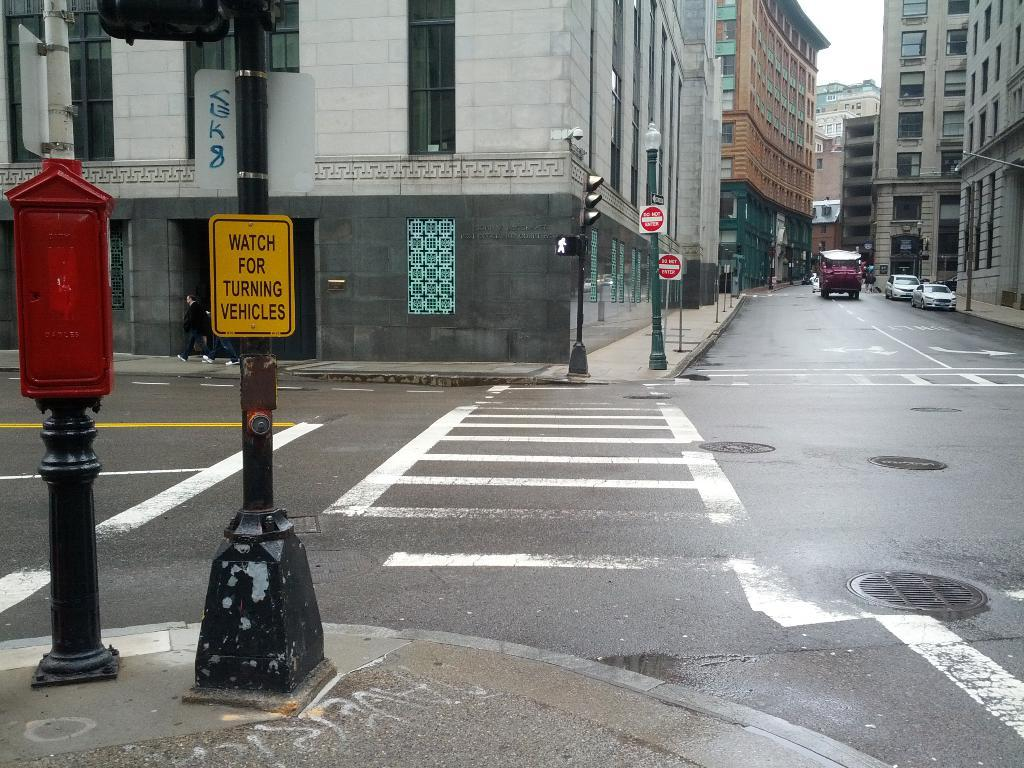<image>
Create a compact narrative representing the image presented. An empty crosswalk that has a yellow sign that warns to watch for turning vehicle. 